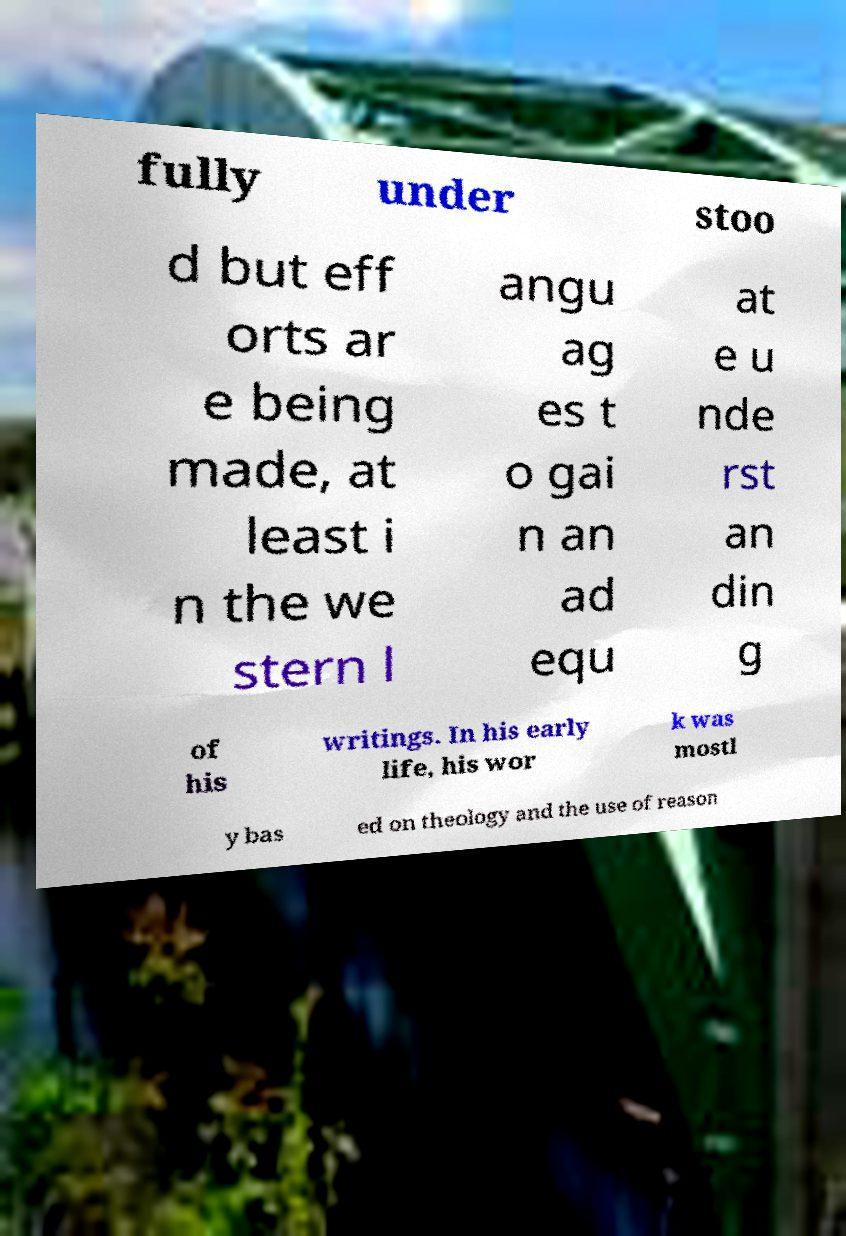Can you read and provide the text displayed in the image?This photo seems to have some interesting text. Can you extract and type it out for me? fully under stoo d but eff orts ar e being made, at least i n the we stern l angu ag es t o gai n an ad equ at e u nde rst an din g of his writings. In his early life, his wor k was mostl y bas ed on theology and the use of reason 